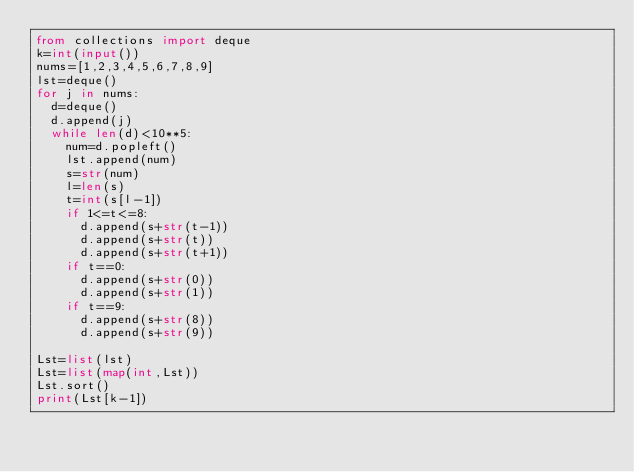Convert code to text. <code><loc_0><loc_0><loc_500><loc_500><_Python_>from collections import deque
k=int(input())
nums=[1,2,3,4,5,6,7,8,9]
lst=deque()
for j in nums:
  d=deque()
  d.append(j)
  while len(d)<10**5:
    num=d.popleft()
    lst.append(num)
    s=str(num)
    l=len(s)
    t=int(s[l-1])
    if 1<=t<=8:
      d.append(s+str(t-1))
      d.append(s+str(t))
      d.append(s+str(t+1))
    if t==0:
      d.append(s+str(0))
      d.append(s+str(1))
    if t==9:
      d.append(s+str(8))
      d.append(s+str(9))

Lst=list(lst)
Lst=list(map(int,Lst))
Lst.sort()
print(Lst[k-1])
    
    
      
   
</code> 